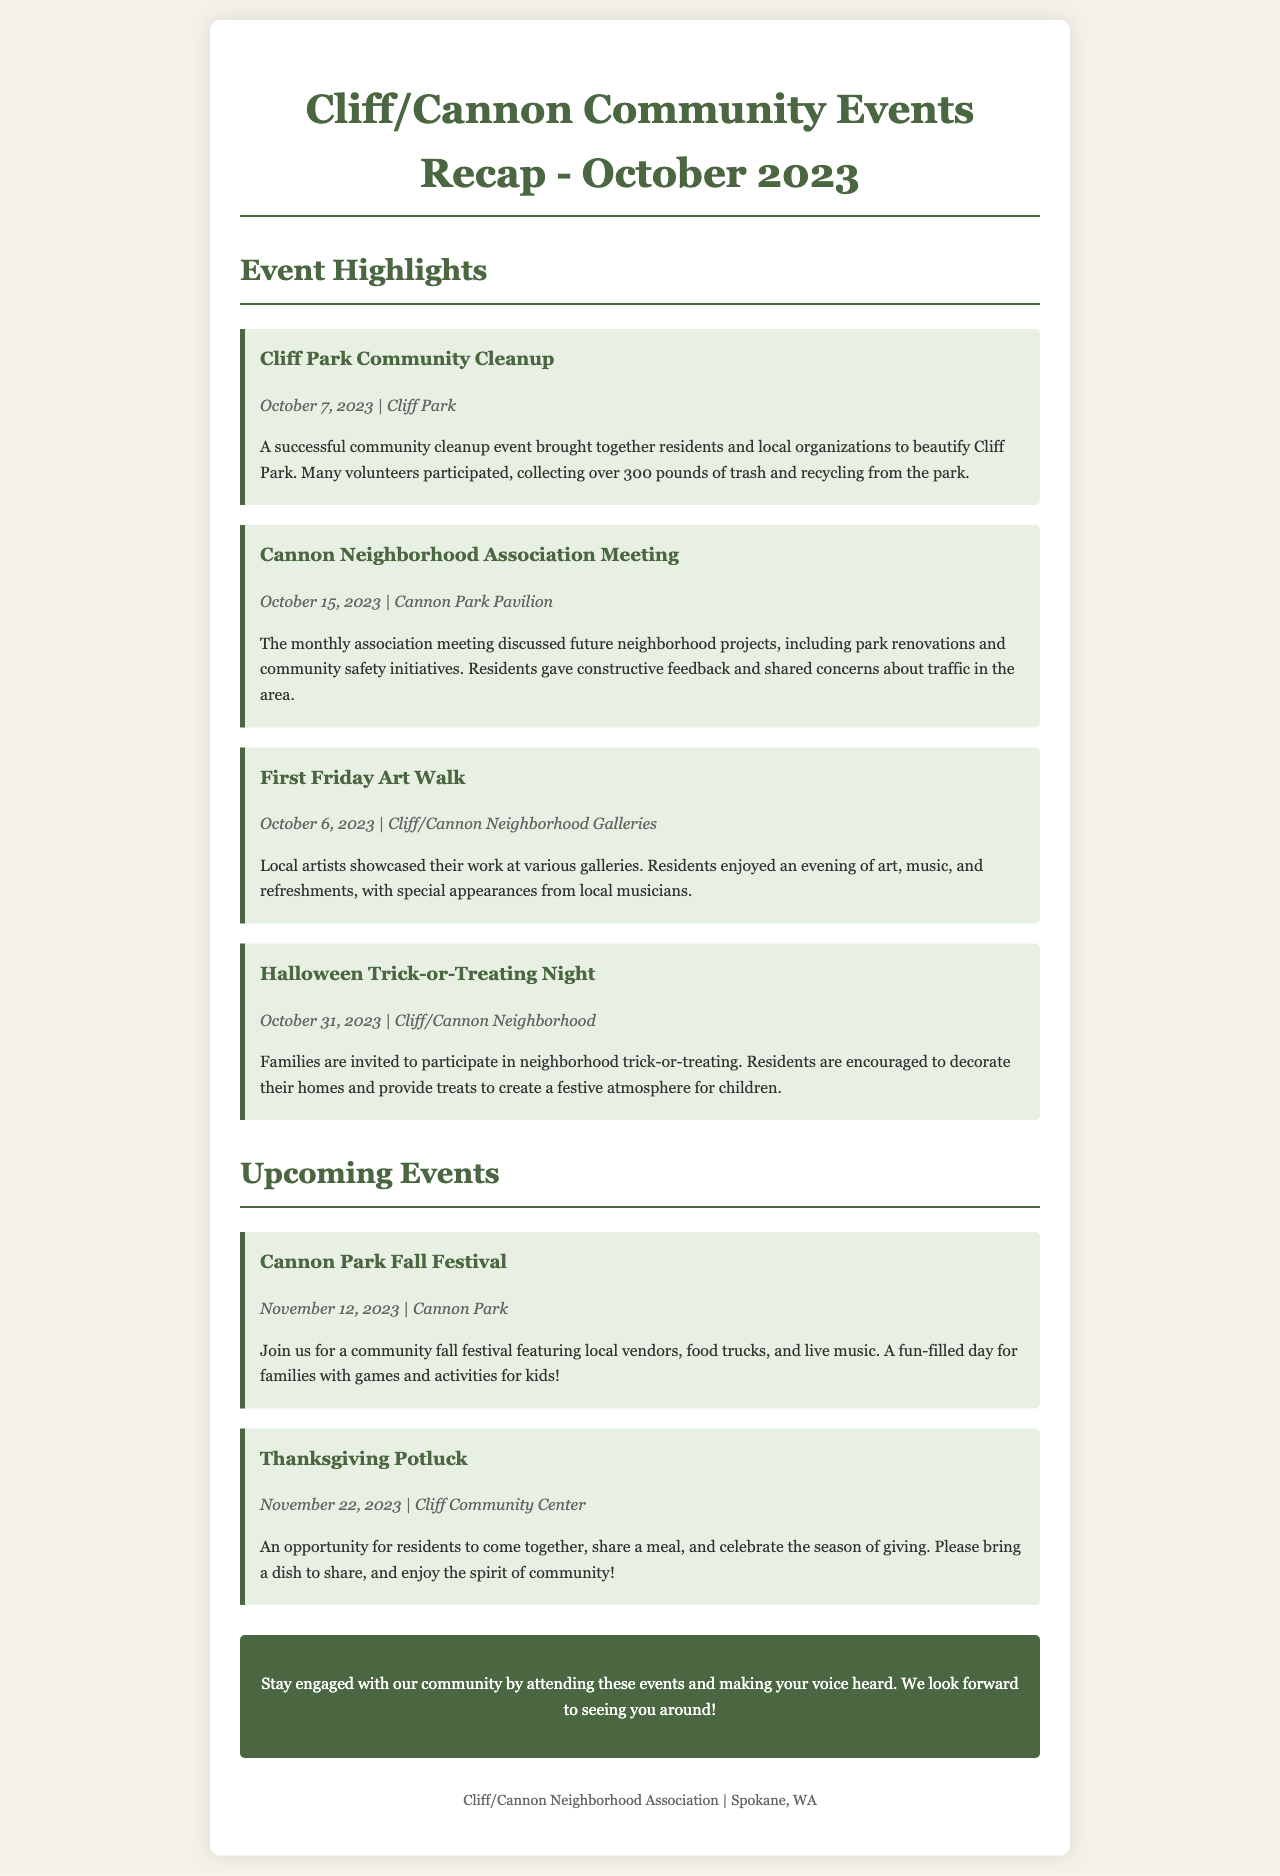What was the date of the Cliff Park Community Cleanup? The date of the Cliff Park Community Cleanup is explicitly stated in the event section of the document.
Answer: October 7, 2023 How many pounds of trash were collected during the community cleanup? The document mentions a specific quantity of trash and recycling collected, which is part of the details of the cleanup event.
Answer: 300 pounds What was discussed in the Cannon Neighborhood Association Meeting? The meeting discussed future neighborhood projects and community concerns, which are mentioned in the detailed description of the event.
Answer: Park renovations and community safety initiatives When is the Halloween Trick-or-Treating Night scheduled? The date for the Halloween event is noted in the upcoming events section of the document.
Answer: October 31, 2023 What is the venue for the Thanksgiving Potluck? The venue for the Thanksgiving Potluck is stated in the event details, specifying where it will take place.
Answer: Cliff Community Center How many upcoming events are listed in the document? The document provides a count of upcoming events, which is a simple retrieval of the events section.
Answer: 2 events What type of activities will be featured at the Cannon Park Fall Festival? The document outlines the types of attractions and activities planned for the festival, highlighting its purpose.
Answer: Local vendors, food trucks, and live music What should residents bring to the Thanksgiving Potluck? The document specifies the items residents are encouraged to bring to the potluck, which is critical for participation.
Answer: A dish to share 